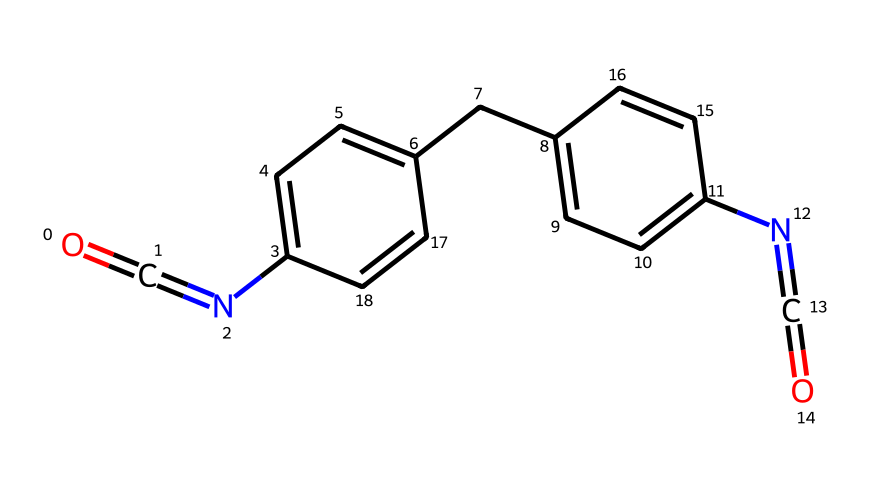What is the molecular formula of this compound? The SMILES notation gives the molecular composition. Counting the atoms represented, carbon (C) is 15, hydrogen (H) is 12, nitrogen (N) is 3, and oxygen (O) is 2. Therefore, combine these counts to form the molecular formula C15H12N3O2.
Answer: C15H12N3O2 How many aromatic rings are present in this molecule? By examining the structure, there are two distinct rings that contain alternating double bonds (the benzene-like structure), indicating they are aromatic. Thus, the count of aromatic rings is two.
Answer: 2 What functional groups can be identified in this chemical structure? The presence of isocyanate (N=C=O) and the aromatic amine (–N–) indicates that both functional groups are present. Therefore, based on these observations, the answer is isocyanate and amine.
Answer: isocyanate and amine What type of chemical reaction would likely involve this isocyanate? Isocyanates are known to undergo reactions with alcohols to form urethanes (or polyurethanes). This is a key reaction in producing polyurethane insulation materials. Therefore, the type of reaction is urethane formation.
Answer: urethane formation What role does the isocyanate group play in energy-efficient insulation materials? The isocyanate group is essential for forming the cross-linked structure of polyurethane foams, enhancing insulation properties by trapping air and reducing thermal conductivity. This is crucial for energy efficiency in construction materials.
Answer: cross-linking agent 